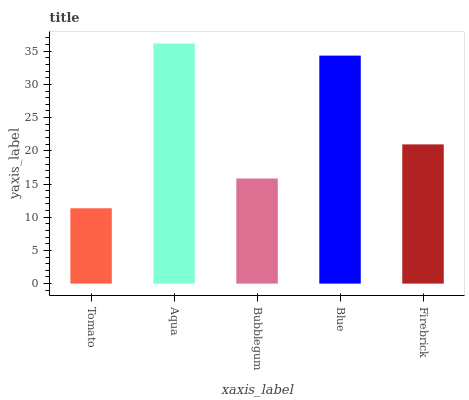Is Bubblegum the minimum?
Answer yes or no. No. Is Bubblegum the maximum?
Answer yes or no. No. Is Aqua greater than Bubblegum?
Answer yes or no. Yes. Is Bubblegum less than Aqua?
Answer yes or no. Yes. Is Bubblegum greater than Aqua?
Answer yes or no. No. Is Aqua less than Bubblegum?
Answer yes or no. No. Is Firebrick the high median?
Answer yes or no. Yes. Is Firebrick the low median?
Answer yes or no. Yes. Is Tomato the high median?
Answer yes or no. No. Is Aqua the low median?
Answer yes or no. No. 